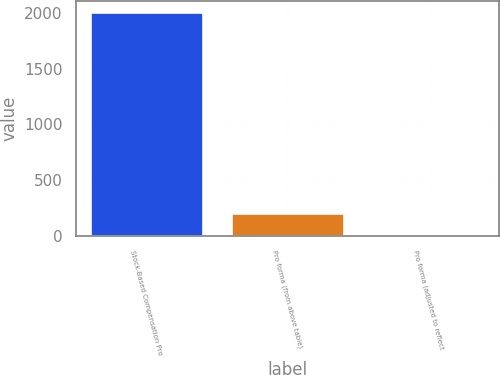Convert chart to OTSL. <chart><loc_0><loc_0><loc_500><loc_500><bar_chart><fcel>Stock-Based Compensation Pro<fcel>Pro forma (from above table)<fcel>Pro forma (adjusted to reflect<nl><fcel>2005<fcel>204.06<fcel>3.96<nl></chart> 